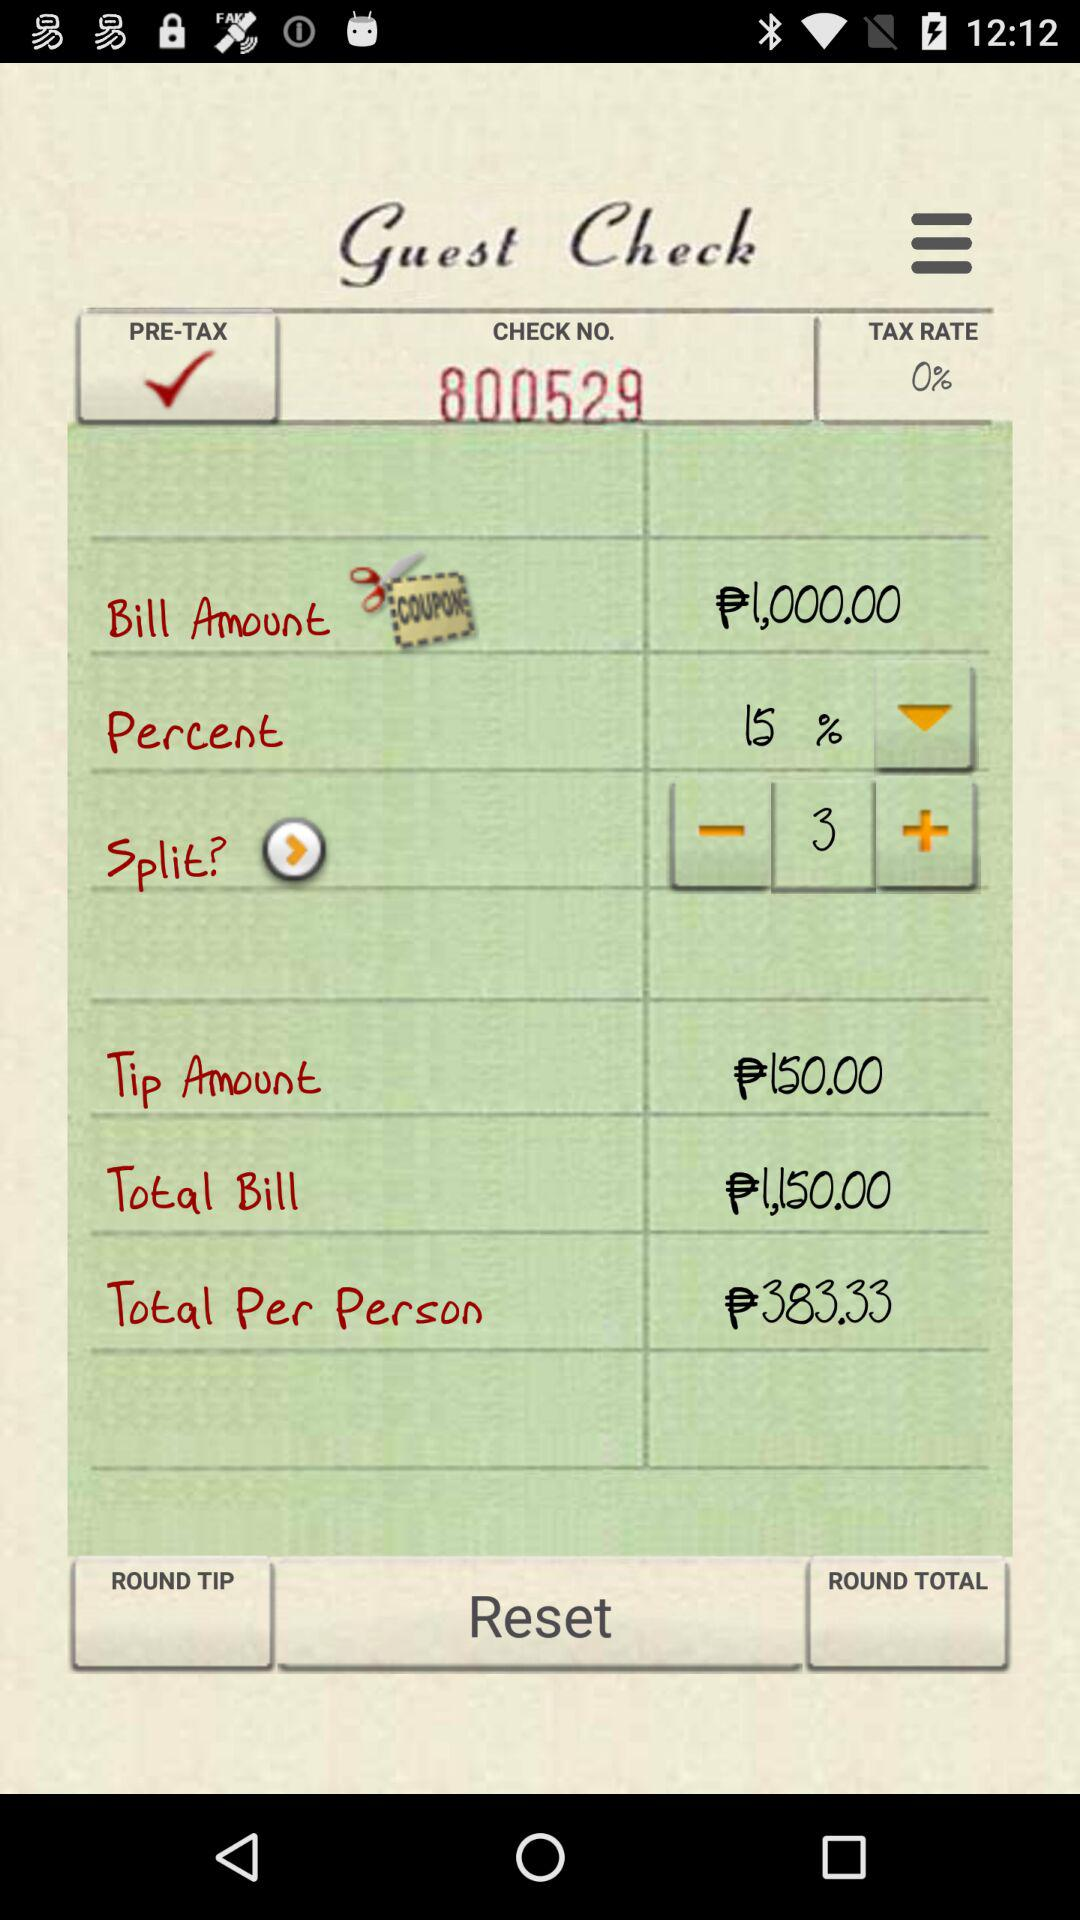What is the total bill? The total bill is ₱1,150. 